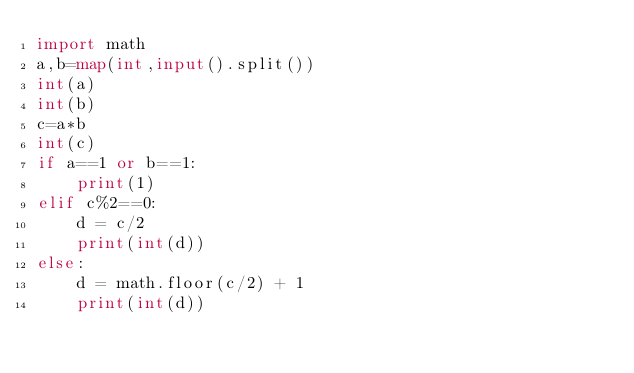Convert code to text. <code><loc_0><loc_0><loc_500><loc_500><_Python_>import math
a,b=map(int,input().split())
int(a)
int(b)
c=a*b
int(c)
if a==1 or b==1:
    print(1)
elif c%2==0:
    d = c/2
    print(int(d))
else:
    d = math.floor(c/2) + 1
    print(int(d))</code> 